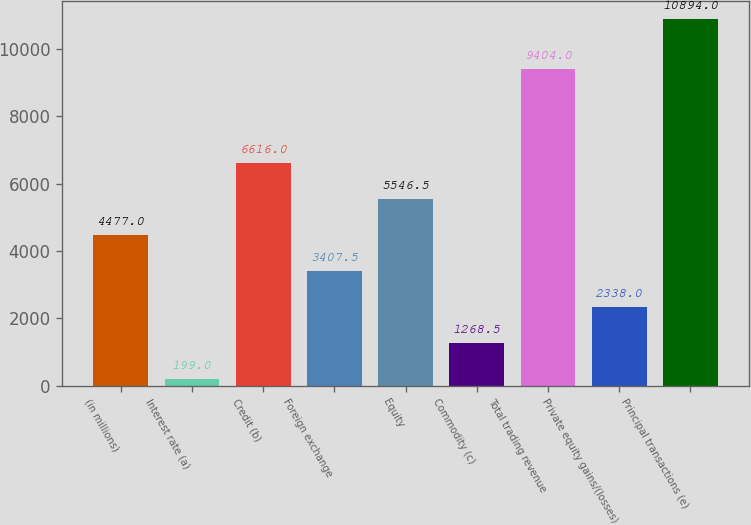Convert chart to OTSL. <chart><loc_0><loc_0><loc_500><loc_500><bar_chart><fcel>(in millions)<fcel>Interest rate (a)<fcel>Credit (b)<fcel>Foreign exchange<fcel>Equity<fcel>Commodity (c)<fcel>Total trading revenue<fcel>Private equity gains/(losses)<fcel>Principal transactions (e)<nl><fcel>4477<fcel>199<fcel>6616<fcel>3407.5<fcel>5546.5<fcel>1268.5<fcel>9404<fcel>2338<fcel>10894<nl></chart> 